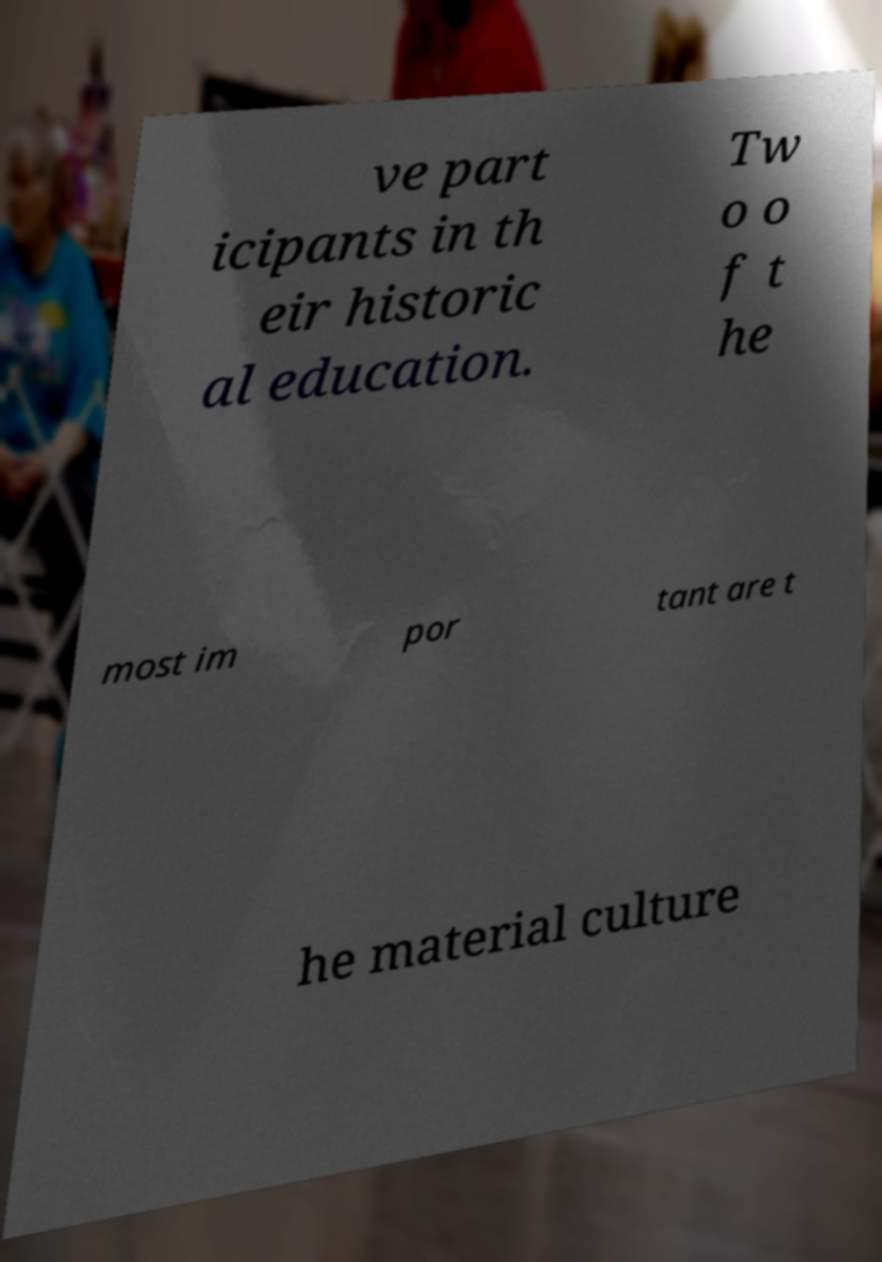There's text embedded in this image that I need extracted. Can you transcribe it verbatim? ve part icipants in th eir historic al education. Tw o o f t he most im por tant are t he material culture 